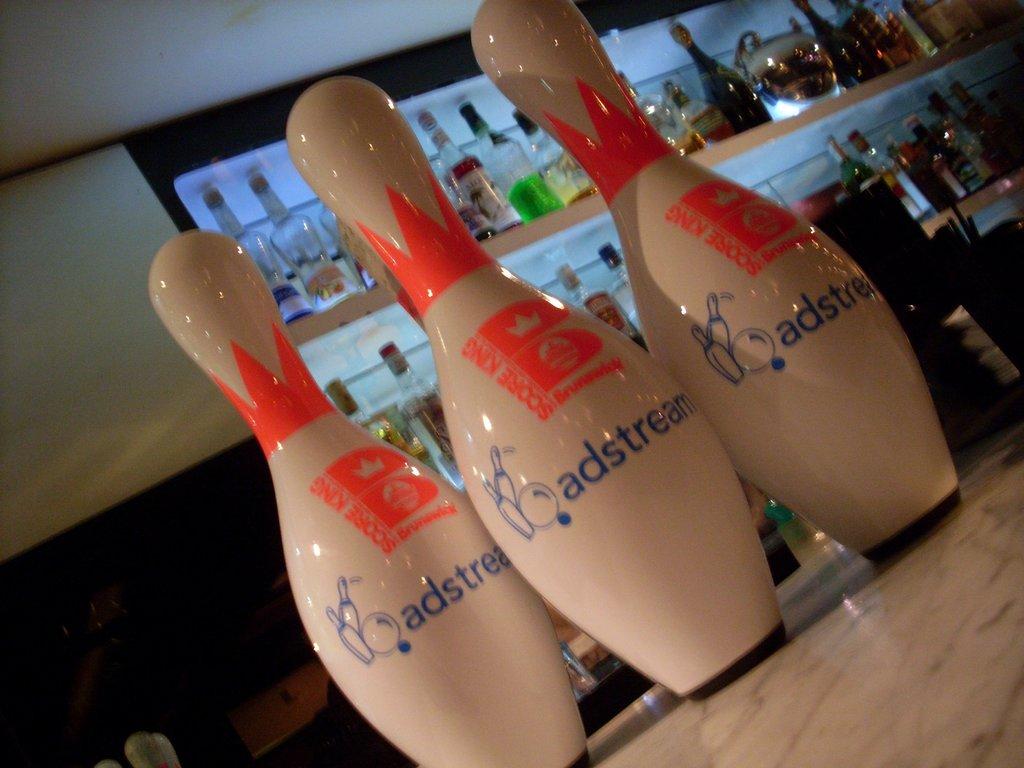What brand is the bowling pin?
Give a very brief answer. Adstream. 